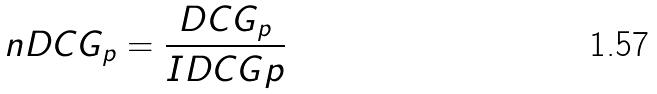<formula> <loc_0><loc_0><loc_500><loc_500>n D C G _ { p } = \frac { D C G _ { p } } { I D C G p }</formula> 